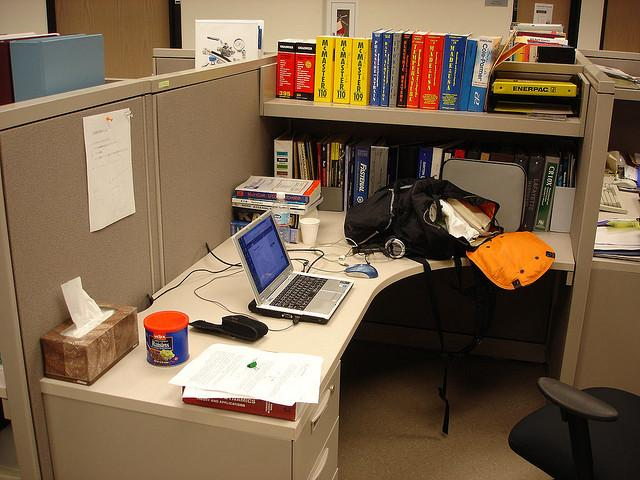What type of internet device is in use at this desk? laptop 